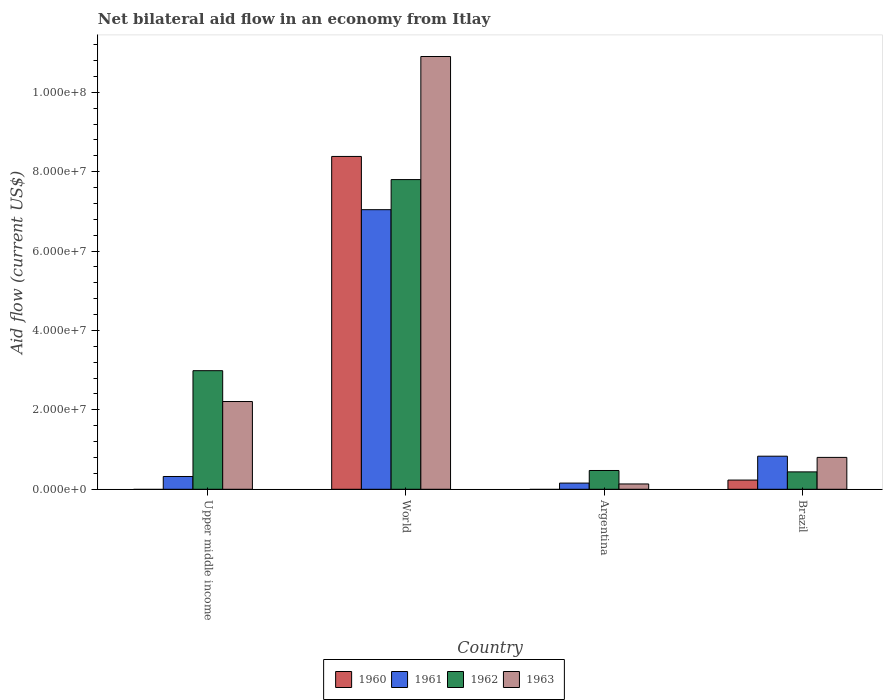How many different coloured bars are there?
Your answer should be compact. 4. Are the number of bars per tick equal to the number of legend labels?
Your response must be concise. No. Are the number of bars on each tick of the X-axis equal?
Make the answer very short. No. In how many cases, is the number of bars for a given country not equal to the number of legend labels?
Give a very brief answer. 2. What is the net bilateral aid flow in 1960 in World?
Provide a succinct answer. 8.38e+07. Across all countries, what is the maximum net bilateral aid flow in 1960?
Your answer should be compact. 8.38e+07. What is the total net bilateral aid flow in 1961 in the graph?
Offer a very short reply. 8.35e+07. What is the difference between the net bilateral aid flow in 1962 in Upper middle income and that in World?
Your answer should be compact. -4.81e+07. What is the difference between the net bilateral aid flow in 1962 in Upper middle income and the net bilateral aid flow in 1963 in Brazil?
Provide a succinct answer. 2.18e+07. What is the average net bilateral aid flow in 1962 per country?
Provide a succinct answer. 2.92e+07. What is the difference between the net bilateral aid flow of/in 1962 and net bilateral aid flow of/in 1960 in World?
Your answer should be very brief. -5.83e+06. What is the ratio of the net bilateral aid flow in 1961 in Upper middle income to that in World?
Your response must be concise. 0.05. Is the net bilateral aid flow in 1963 in Argentina less than that in Upper middle income?
Make the answer very short. Yes. Is the difference between the net bilateral aid flow in 1962 in Brazil and World greater than the difference between the net bilateral aid flow in 1960 in Brazil and World?
Your answer should be compact. Yes. What is the difference between the highest and the second highest net bilateral aid flow in 1962?
Make the answer very short. 7.33e+07. What is the difference between the highest and the lowest net bilateral aid flow in 1963?
Provide a succinct answer. 1.08e+08. In how many countries, is the net bilateral aid flow in 1960 greater than the average net bilateral aid flow in 1960 taken over all countries?
Your answer should be very brief. 1. Is the sum of the net bilateral aid flow in 1961 in Upper middle income and World greater than the maximum net bilateral aid flow in 1962 across all countries?
Offer a very short reply. No. Is it the case that in every country, the sum of the net bilateral aid flow in 1963 and net bilateral aid flow in 1961 is greater than the net bilateral aid flow in 1960?
Your answer should be very brief. Yes. Are the values on the major ticks of Y-axis written in scientific E-notation?
Offer a terse response. Yes. Does the graph contain any zero values?
Keep it short and to the point. Yes. Does the graph contain grids?
Provide a succinct answer. No. How many legend labels are there?
Provide a succinct answer. 4. What is the title of the graph?
Your response must be concise. Net bilateral aid flow in an economy from Itlay. Does "1986" appear as one of the legend labels in the graph?
Keep it short and to the point. No. What is the label or title of the X-axis?
Your response must be concise. Country. What is the Aid flow (current US$) in 1961 in Upper middle income?
Give a very brief answer. 3.22e+06. What is the Aid flow (current US$) in 1962 in Upper middle income?
Your answer should be very brief. 2.99e+07. What is the Aid flow (current US$) in 1963 in Upper middle income?
Keep it short and to the point. 2.21e+07. What is the Aid flow (current US$) in 1960 in World?
Make the answer very short. 8.38e+07. What is the Aid flow (current US$) of 1961 in World?
Provide a short and direct response. 7.04e+07. What is the Aid flow (current US$) of 1962 in World?
Your answer should be compact. 7.80e+07. What is the Aid flow (current US$) of 1963 in World?
Offer a very short reply. 1.09e+08. What is the Aid flow (current US$) of 1961 in Argentina?
Provide a succinct answer. 1.56e+06. What is the Aid flow (current US$) of 1962 in Argentina?
Give a very brief answer. 4.73e+06. What is the Aid flow (current US$) in 1963 in Argentina?
Offer a very short reply. 1.34e+06. What is the Aid flow (current US$) in 1960 in Brazil?
Ensure brevity in your answer.  2.32e+06. What is the Aid flow (current US$) in 1961 in Brazil?
Give a very brief answer. 8.33e+06. What is the Aid flow (current US$) of 1962 in Brazil?
Offer a terse response. 4.38e+06. What is the Aid flow (current US$) in 1963 in Brazil?
Provide a short and direct response. 8.03e+06. Across all countries, what is the maximum Aid flow (current US$) in 1960?
Your answer should be very brief. 8.38e+07. Across all countries, what is the maximum Aid flow (current US$) in 1961?
Offer a very short reply. 7.04e+07. Across all countries, what is the maximum Aid flow (current US$) in 1962?
Give a very brief answer. 7.80e+07. Across all countries, what is the maximum Aid flow (current US$) in 1963?
Give a very brief answer. 1.09e+08. Across all countries, what is the minimum Aid flow (current US$) in 1960?
Your answer should be compact. 0. Across all countries, what is the minimum Aid flow (current US$) of 1961?
Offer a terse response. 1.56e+06. Across all countries, what is the minimum Aid flow (current US$) in 1962?
Your answer should be compact. 4.38e+06. Across all countries, what is the minimum Aid flow (current US$) in 1963?
Your answer should be very brief. 1.34e+06. What is the total Aid flow (current US$) of 1960 in the graph?
Provide a succinct answer. 8.62e+07. What is the total Aid flow (current US$) of 1961 in the graph?
Give a very brief answer. 8.35e+07. What is the total Aid flow (current US$) of 1962 in the graph?
Ensure brevity in your answer.  1.17e+08. What is the total Aid flow (current US$) in 1963 in the graph?
Ensure brevity in your answer.  1.40e+08. What is the difference between the Aid flow (current US$) in 1961 in Upper middle income and that in World?
Offer a terse response. -6.72e+07. What is the difference between the Aid flow (current US$) of 1962 in Upper middle income and that in World?
Give a very brief answer. -4.81e+07. What is the difference between the Aid flow (current US$) in 1963 in Upper middle income and that in World?
Offer a very short reply. -8.69e+07. What is the difference between the Aid flow (current US$) of 1961 in Upper middle income and that in Argentina?
Make the answer very short. 1.66e+06. What is the difference between the Aid flow (current US$) in 1962 in Upper middle income and that in Argentina?
Your response must be concise. 2.51e+07. What is the difference between the Aid flow (current US$) in 1963 in Upper middle income and that in Argentina?
Offer a very short reply. 2.08e+07. What is the difference between the Aid flow (current US$) in 1961 in Upper middle income and that in Brazil?
Make the answer very short. -5.11e+06. What is the difference between the Aid flow (current US$) in 1962 in Upper middle income and that in Brazil?
Offer a very short reply. 2.55e+07. What is the difference between the Aid flow (current US$) of 1963 in Upper middle income and that in Brazil?
Your answer should be very brief. 1.41e+07. What is the difference between the Aid flow (current US$) in 1961 in World and that in Argentina?
Your response must be concise. 6.89e+07. What is the difference between the Aid flow (current US$) in 1962 in World and that in Argentina?
Make the answer very short. 7.33e+07. What is the difference between the Aid flow (current US$) in 1963 in World and that in Argentina?
Offer a terse response. 1.08e+08. What is the difference between the Aid flow (current US$) of 1960 in World and that in Brazil?
Provide a succinct answer. 8.15e+07. What is the difference between the Aid flow (current US$) in 1961 in World and that in Brazil?
Provide a short and direct response. 6.21e+07. What is the difference between the Aid flow (current US$) of 1962 in World and that in Brazil?
Give a very brief answer. 7.36e+07. What is the difference between the Aid flow (current US$) in 1963 in World and that in Brazil?
Your answer should be very brief. 1.01e+08. What is the difference between the Aid flow (current US$) in 1961 in Argentina and that in Brazil?
Offer a terse response. -6.77e+06. What is the difference between the Aid flow (current US$) in 1962 in Argentina and that in Brazil?
Give a very brief answer. 3.50e+05. What is the difference between the Aid flow (current US$) of 1963 in Argentina and that in Brazil?
Make the answer very short. -6.69e+06. What is the difference between the Aid flow (current US$) in 1961 in Upper middle income and the Aid flow (current US$) in 1962 in World?
Provide a short and direct response. -7.48e+07. What is the difference between the Aid flow (current US$) in 1961 in Upper middle income and the Aid flow (current US$) in 1963 in World?
Your answer should be compact. -1.06e+08. What is the difference between the Aid flow (current US$) in 1962 in Upper middle income and the Aid flow (current US$) in 1963 in World?
Offer a terse response. -7.91e+07. What is the difference between the Aid flow (current US$) of 1961 in Upper middle income and the Aid flow (current US$) of 1962 in Argentina?
Your answer should be very brief. -1.51e+06. What is the difference between the Aid flow (current US$) in 1961 in Upper middle income and the Aid flow (current US$) in 1963 in Argentina?
Your answer should be compact. 1.88e+06. What is the difference between the Aid flow (current US$) of 1962 in Upper middle income and the Aid flow (current US$) of 1963 in Argentina?
Give a very brief answer. 2.85e+07. What is the difference between the Aid flow (current US$) of 1961 in Upper middle income and the Aid flow (current US$) of 1962 in Brazil?
Your answer should be very brief. -1.16e+06. What is the difference between the Aid flow (current US$) in 1961 in Upper middle income and the Aid flow (current US$) in 1963 in Brazil?
Make the answer very short. -4.81e+06. What is the difference between the Aid flow (current US$) in 1962 in Upper middle income and the Aid flow (current US$) in 1963 in Brazil?
Your answer should be very brief. 2.18e+07. What is the difference between the Aid flow (current US$) of 1960 in World and the Aid flow (current US$) of 1961 in Argentina?
Keep it short and to the point. 8.23e+07. What is the difference between the Aid flow (current US$) in 1960 in World and the Aid flow (current US$) in 1962 in Argentina?
Give a very brief answer. 7.91e+07. What is the difference between the Aid flow (current US$) in 1960 in World and the Aid flow (current US$) in 1963 in Argentina?
Provide a short and direct response. 8.25e+07. What is the difference between the Aid flow (current US$) of 1961 in World and the Aid flow (current US$) of 1962 in Argentina?
Keep it short and to the point. 6.57e+07. What is the difference between the Aid flow (current US$) of 1961 in World and the Aid flow (current US$) of 1963 in Argentina?
Provide a succinct answer. 6.91e+07. What is the difference between the Aid flow (current US$) of 1962 in World and the Aid flow (current US$) of 1963 in Argentina?
Make the answer very short. 7.67e+07. What is the difference between the Aid flow (current US$) of 1960 in World and the Aid flow (current US$) of 1961 in Brazil?
Offer a terse response. 7.55e+07. What is the difference between the Aid flow (current US$) in 1960 in World and the Aid flow (current US$) in 1962 in Brazil?
Your response must be concise. 7.94e+07. What is the difference between the Aid flow (current US$) in 1960 in World and the Aid flow (current US$) in 1963 in Brazil?
Ensure brevity in your answer.  7.58e+07. What is the difference between the Aid flow (current US$) in 1961 in World and the Aid flow (current US$) in 1962 in Brazil?
Give a very brief answer. 6.60e+07. What is the difference between the Aid flow (current US$) in 1961 in World and the Aid flow (current US$) in 1963 in Brazil?
Your answer should be very brief. 6.24e+07. What is the difference between the Aid flow (current US$) of 1962 in World and the Aid flow (current US$) of 1963 in Brazil?
Offer a very short reply. 7.00e+07. What is the difference between the Aid flow (current US$) of 1961 in Argentina and the Aid flow (current US$) of 1962 in Brazil?
Give a very brief answer. -2.82e+06. What is the difference between the Aid flow (current US$) of 1961 in Argentina and the Aid flow (current US$) of 1963 in Brazil?
Keep it short and to the point. -6.47e+06. What is the difference between the Aid flow (current US$) in 1962 in Argentina and the Aid flow (current US$) in 1963 in Brazil?
Your response must be concise. -3.30e+06. What is the average Aid flow (current US$) of 1960 per country?
Provide a short and direct response. 2.15e+07. What is the average Aid flow (current US$) in 1961 per country?
Make the answer very short. 2.09e+07. What is the average Aid flow (current US$) in 1962 per country?
Your answer should be very brief. 2.92e+07. What is the average Aid flow (current US$) in 1963 per country?
Make the answer very short. 3.51e+07. What is the difference between the Aid flow (current US$) in 1961 and Aid flow (current US$) in 1962 in Upper middle income?
Your response must be concise. -2.66e+07. What is the difference between the Aid flow (current US$) in 1961 and Aid flow (current US$) in 1963 in Upper middle income?
Offer a terse response. -1.89e+07. What is the difference between the Aid flow (current US$) in 1962 and Aid flow (current US$) in 1963 in Upper middle income?
Give a very brief answer. 7.77e+06. What is the difference between the Aid flow (current US$) of 1960 and Aid flow (current US$) of 1961 in World?
Give a very brief answer. 1.34e+07. What is the difference between the Aid flow (current US$) in 1960 and Aid flow (current US$) in 1962 in World?
Make the answer very short. 5.83e+06. What is the difference between the Aid flow (current US$) of 1960 and Aid flow (current US$) of 1963 in World?
Your answer should be very brief. -2.52e+07. What is the difference between the Aid flow (current US$) in 1961 and Aid flow (current US$) in 1962 in World?
Offer a very short reply. -7.58e+06. What is the difference between the Aid flow (current US$) in 1961 and Aid flow (current US$) in 1963 in World?
Provide a short and direct response. -3.86e+07. What is the difference between the Aid flow (current US$) in 1962 and Aid flow (current US$) in 1963 in World?
Your answer should be compact. -3.10e+07. What is the difference between the Aid flow (current US$) of 1961 and Aid flow (current US$) of 1962 in Argentina?
Provide a short and direct response. -3.17e+06. What is the difference between the Aid flow (current US$) of 1961 and Aid flow (current US$) of 1963 in Argentina?
Your answer should be very brief. 2.20e+05. What is the difference between the Aid flow (current US$) in 1962 and Aid flow (current US$) in 1963 in Argentina?
Offer a very short reply. 3.39e+06. What is the difference between the Aid flow (current US$) of 1960 and Aid flow (current US$) of 1961 in Brazil?
Offer a terse response. -6.01e+06. What is the difference between the Aid flow (current US$) in 1960 and Aid flow (current US$) in 1962 in Brazil?
Give a very brief answer. -2.06e+06. What is the difference between the Aid flow (current US$) of 1960 and Aid flow (current US$) of 1963 in Brazil?
Ensure brevity in your answer.  -5.71e+06. What is the difference between the Aid flow (current US$) in 1961 and Aid flow (current US$) in 1962 in Brazil?
Your response must be concise. 3.95e+06. What is the difference between the Aid flow (current US$) of 1961 and Aid flow (current US$) of 1963 in Brazil?
Your answer should be compact. 3.00e+05. What is the difference between the Aid flow (current US$) in 1962 and Aid flow (current US$) in 1963 in Brazil?
Your answer should be compact. -3.65e+06. What is the ratio of the Aid flow (current US$) of 1961 in Upper middle income to that in World?
Provide a succinct answer. 0.05. What is the ratio of the Aid flow (current US$) of 1962 in Upper middle income to that in World?
Your answer should be very brief. 0.38. What is the ratio of the Aid flow (current US$) of 1963 in Upper middle income to that in World?
Your answer should be compact. 0.2. What is the ratio of the Aid flow (current US$) in 1961 in Upper middle income to that in Argentina?
Make the answer very short. 2.06. What is the ratio of the Aid flow (current US$) in 1962 in Upper middle income to that in Argentina?
Your response must be concise. 6.32. What is the ratio of the Aid flow (current US$) of 1963 in Upper middle income to that in Argentina?
Your answer should be compact. 16.49. What is the ratio of the Aid flow (current US$) of 1961 in Upper middle income to that in Brazil?
Provide a short and direct response. 0.39. What is the ratio of the Aid flow (current US$) of 1962 in Upper middle income to that in Brazil?
Provide a short and direct response. 6.82. What is the ratio of the Aid flow (current US$) of 1963 in Upper middle income to that in Brazil?
Provide a succinct answer. 2.75. What is the ratio of the Aid flow (current US$) of 1961 in World to that in Argentina?
Your answer should be very brief. 45.14. What is the ratio of the Aid flow (current US$) of 1962 in World to that in Argentina?
Your answer should be compact. 16.49. What is the ratio of the Aid flow (current US$) in 1963 in World to that in Argentina?
Your answer should be compact. 81.34. What is the ratio of the Aid flow (current US$) of 1960 in World to that in Brazil?
Keep it short and to the point. 36.13. What is the ratio of the Aid flow (current US$) of 1961 in World to that in Brazil?
Your response must be concise. 8.45. What is the ratio of the Aid flow (current US$) of 1962 in World to that in Brazil?
Ensure brevity in your answer.  17.81. What is the ratio of the Aid flow (current US$) of 1963 in World to that in Brazil?
Your response must be concise. 13.57. What is the ratio of the Aid flow (current US$) in 1961 in Argentina to that in Brazil?
Provide a succinct answer. 0.19. What is the ratio of the Aid flow (current US$) of 1962 in Argentina to that in Brazil?
Your answer should be very brief. 1.08. What is the ratio of the Aid flow (current US$) in 1963 in Argentina to that in Brazil?
Offer a very short reply. 0.17. What is the difference between the highest and the second highest Aid flow (current US$) of 1961?
Your answer should be compact. 6.21e+07. What is the difference between the highest and the second highest Aid flow (current US$) in 1962?
Offer a terse response. 4.81e+07. What is the difference between the highest and the second highest Aid flow (current US$) in 1963?
Your response must be concise. 8.69e+07. What is the difference between the highest and the lowest Aid flow (current US$) in 1960?
Provide a short and direct response. 8.38e+07. What is the difference between the highest and the lowest Aid flow (current US$) in 1961?
Your answer should be very brief. 6.89e+07. What is the difference between the highest and the lowest Aid flow (current US$) in 1962?
Make the answer very short. 7.36e+07. What is the difference between the highest and the lowest Aid flow (current US$) of 1963?
Ensure brevity in your answer.  1.08e+08. 